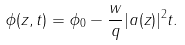<formula> <loc_0><loc_0><loc_500><loc_500>\phi ( z , t ) = \phi _ { 0 } - \frac { w } { q } | a ( z ) | ^ { 2 } t .</formula> 